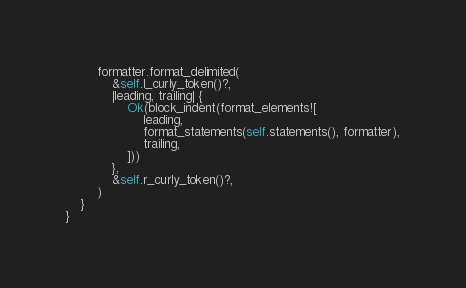<code> <loc_0><loc_0><loc_500><loc_500><_Rust_>        formatter.format_delimited(
            &self.l_curly_token()?,
            |leading, trailing| {
                Ok(block_indent(format_elements![
                    leading,
                    format_statements(self.statements(), formatter),
                    trailing,
                ]))
            },
            &self.r_curly_token()?,
        )
    }
}
</code> 